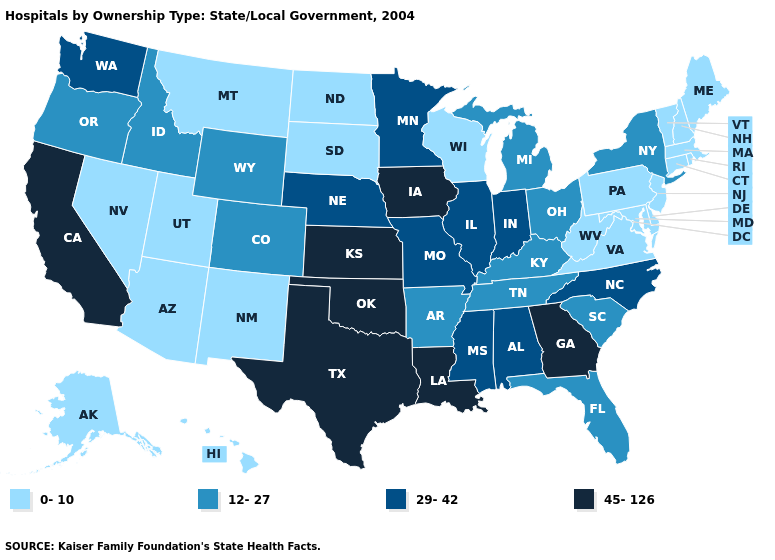Does the map have missing data?
Concise answer only. No. Name the states that have a value in the range 45-126?
Concise answer only. California, Georgia, Iowa, Kansas, Louisiana, Oklahoma, Texas. Does the first symbol in the legend represent the smallest category?
Write a very short answer. Yes. Name the states that have a value in the range 12-27?
Concise answer only. Arkansas, Colorado, Florida, Idaho, Kentucky, Michigan, New York, Ohio, Oregon, South Carolina, Tennessee, Wyoming. Which states have the lowest value in the USA?
Write a very short answer. Alaska, Arizona, Connecticut, Delaware, Hawaii, Maine, Maryland, Massachusetts, Montana, Nevada, New Hampshire, New Jersey, New Mexico, North Dakota, Pennsylvania, Rhode Island, South Dakota, Utah, Vermont, Virginia, West Virginia, Wisconsin. Does Florida have the highest value in the South?
Be succinct. No. What is the value of Idaho?
Answer briefly. 12-27. How many symbols are there in the legend?
Concise answer only. 4. Among the states that border North Carolina , does South Carolina have the highest value?
Answer briefly. No. What is the value of Michigan?
Concise answer only. 12-27. What is the highest value in states that border Illinois?
Keep it brief. 45-126. Which states have the highest value in the USA?
Give a very brief answer. California, Georgia, Iowa, Kansas, Louisiana, Oklahoma, Texas. Name the states that have a value in the range 12-27?
Concise answer only. Arkansas, Colorado, Florida, Idaho, Kentucky, Michigan, New York, Ohio, Oregon, South Carolina, Tennessee, Wyoming. What is the value of Louisiana?
Answer briefly. 45-126. Name the states that have a value in the range 45-126?
Be succinct. California, Georgia, Iowa, Kansas, Louisiana, Oklahoma, Texas. 